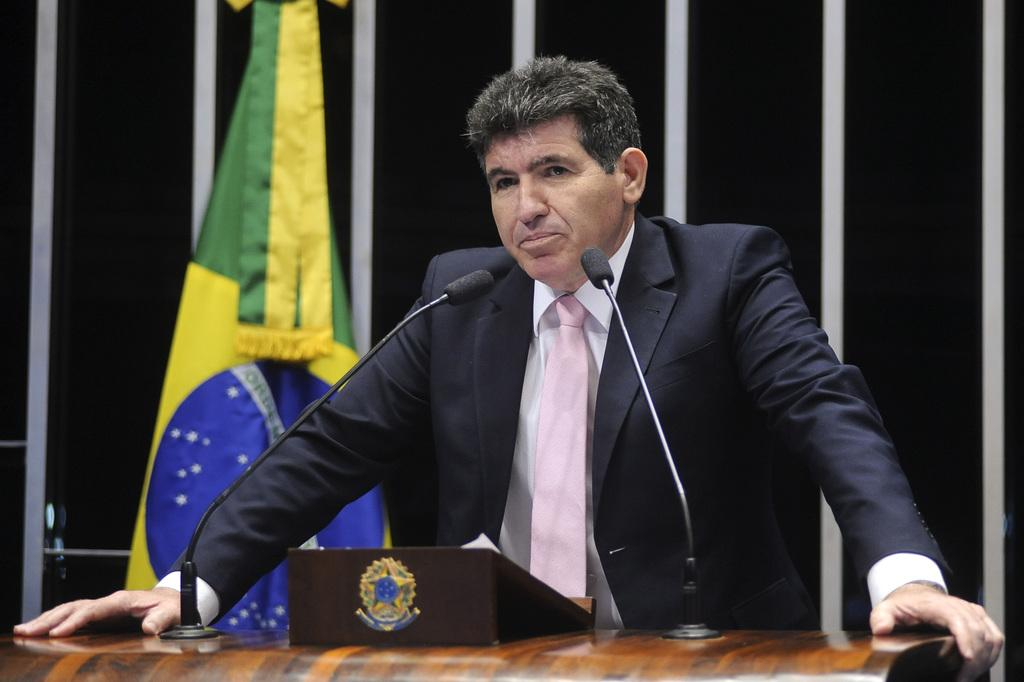What is the person in the image doing? There is a person standing on the podium. What can be seen on the podium with the person? There are two microphones on the podium. What else is on the podium? There is an object on the podium. What is visible on the wall behind the person? There is a flag on the wall behind the person. What type of coal is being used to power the microphones in the image? There is no coal present in the image, and the microphones are not powered by coal. 